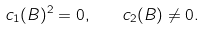<formula> <loc_0><loc_0><loc_500><loc_500>c _ { 1 } ( B ) ^ { 2 } = 0 , \quad c _ { 2 } ( B ) \neq 0 .</formula> 